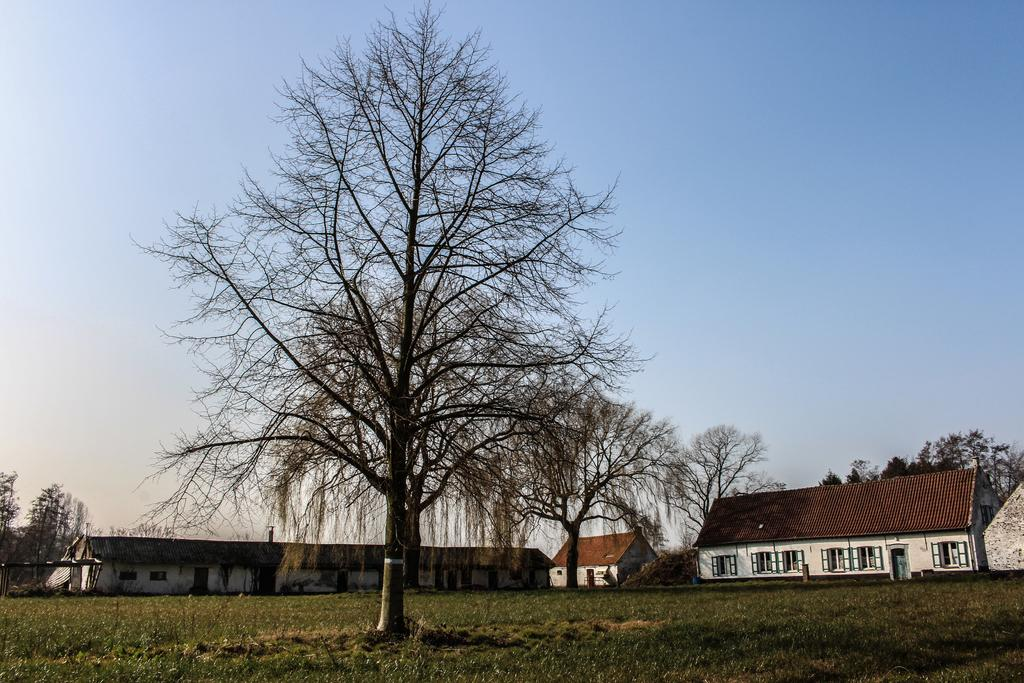What type of vegetation can be seen in the image? There are trees in the image. What part of the natural environment is visible in the image? The sky is visible in the image. What structure is located in the middle of the image? There is a building in the middle of the image. What type of crate is being used for arithmetic in the image? There is no crate or arithmetic present in the image. What type of expansion is visible in the image? There is no expansion visible in the image; it features trees, the sky, and a building. 